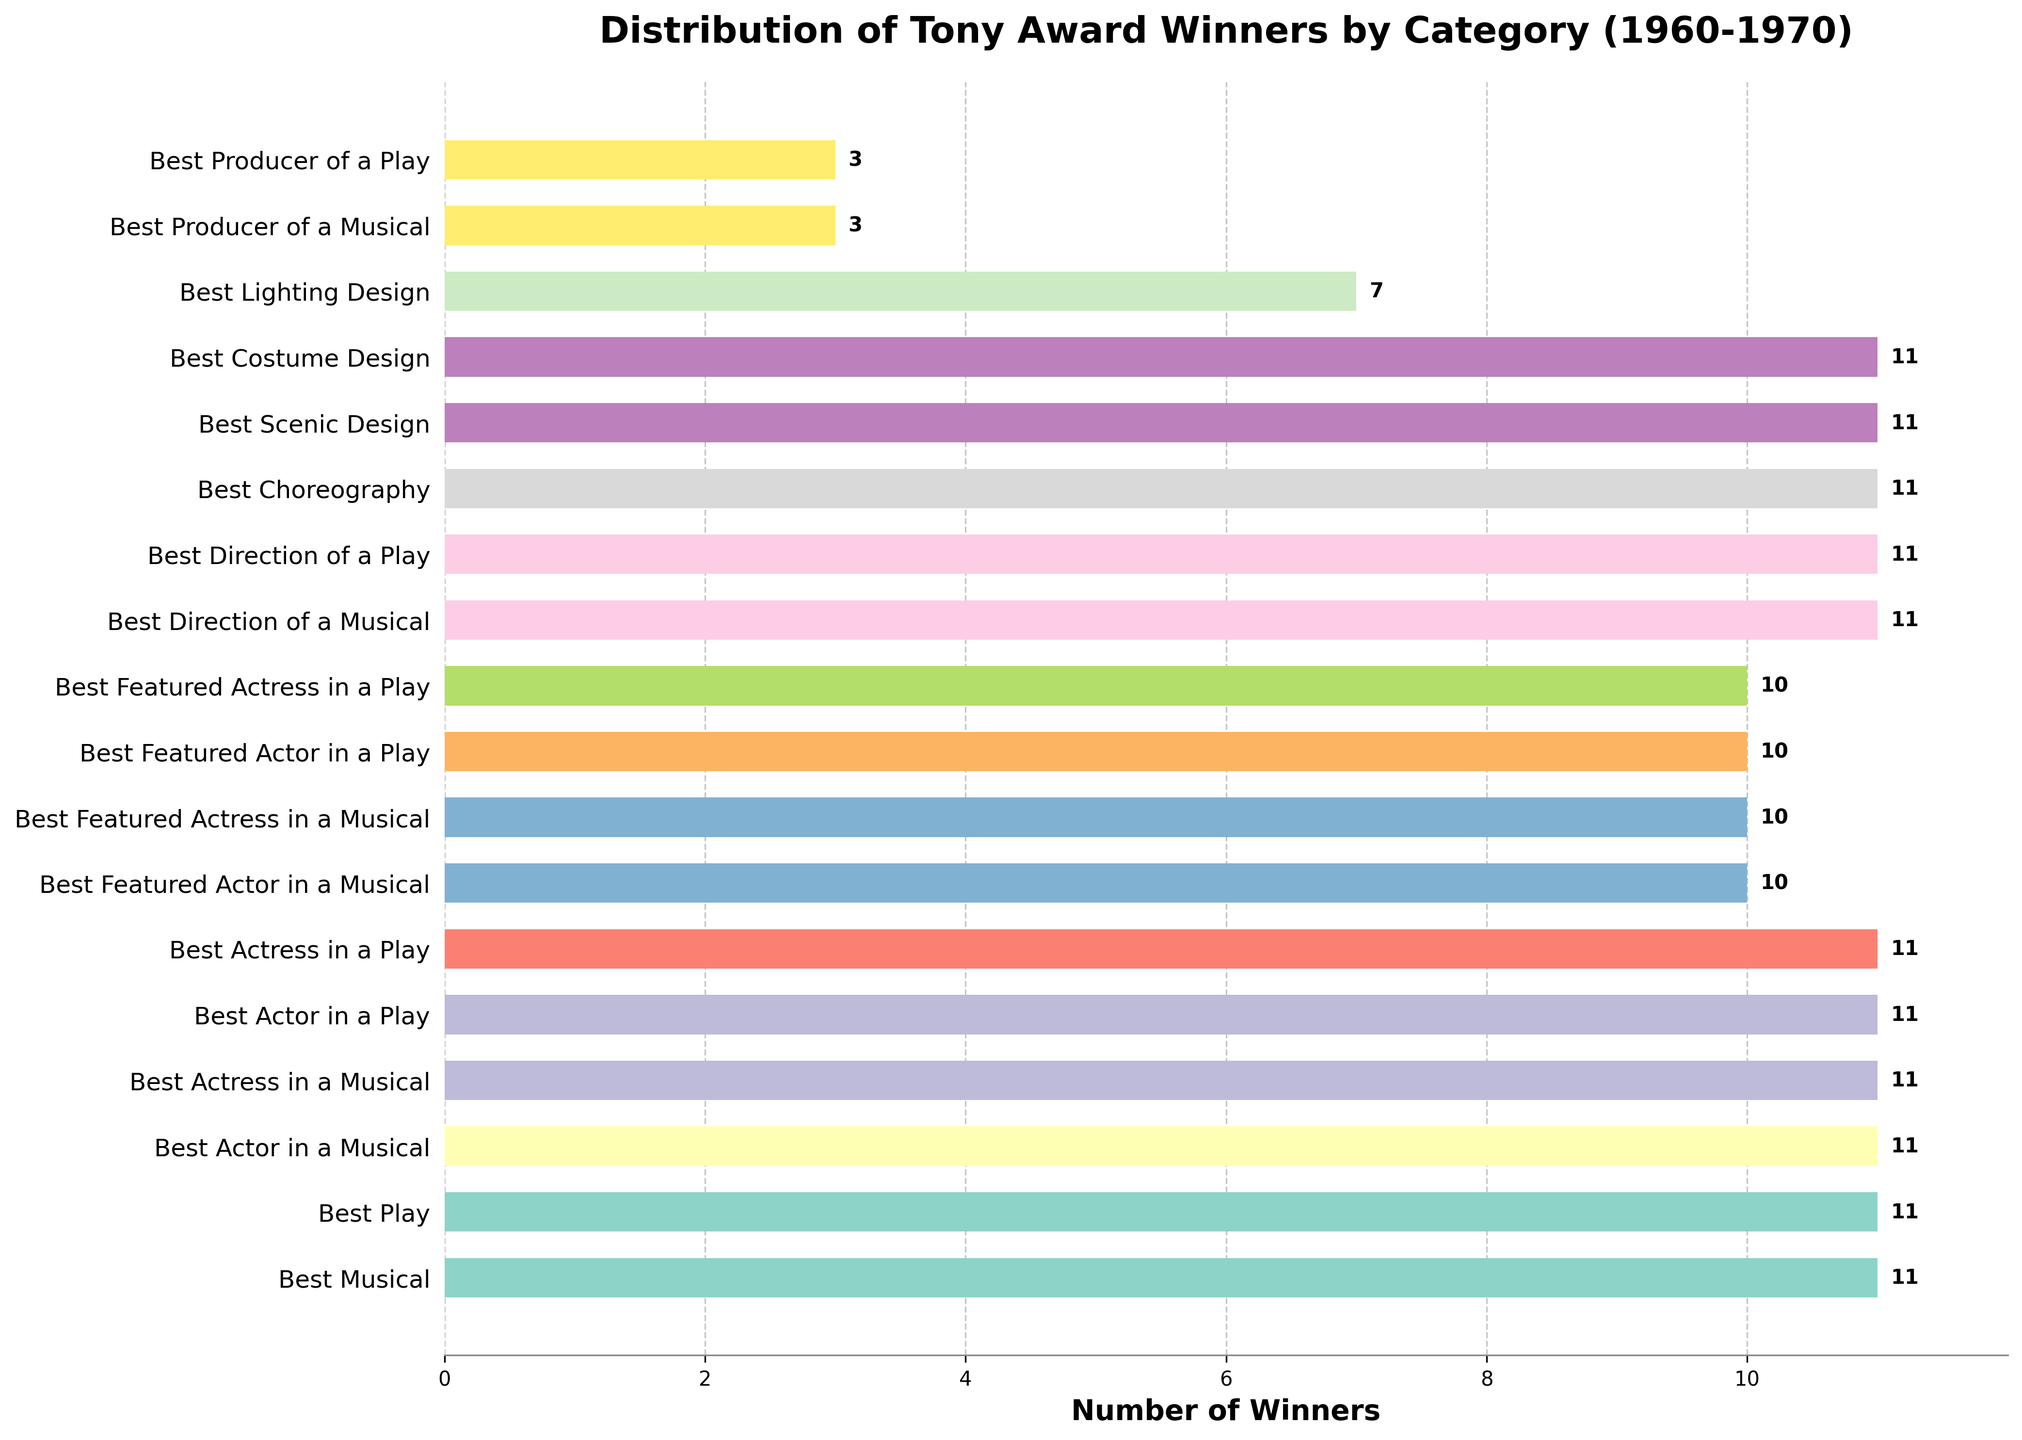What's the most awarded category? The most awarded categories are tied; many categories received 11 awards each. Visually, the bars for categories like Best Musical, Best Play, and others at the top have the same length.
Answer: Best Musical, Best Play, Best Actor in a Musical, Best Actress in a Musical, Best Actor in a Play, Best Actress in a Play, Best Direction of a Musical, Best Direction of a Play, Best Choreography, Best Scenic Design, Best Costume Design Which category received the least number of awards? By comparing the lengths of the bars, the shortest bars correspond to Best Producer of a Musical and Best Producer of a Play, both having notably fewer awards than other categories.
Answer: Best Producer of a Musical, Best Producer of a Play How many more awards did the category with the highest number receive compared to the one with the lowest? The highest number of awards any category received is 11, while the lowest is 3. The difference is calculated as 11 - 3.
Answer: 8 What's the total number of awards given in \*"Best Actor*" categories? Summing the awards for Best Actor in a Musical, Best Actress in a Musical, Best Actor in a Play, and Best Actress in a Play gives us: 11 + 11 + 11 + 11
Answer: 44 Do more communicative work categories (Best Direction of a Musical, Best Direction of a Play) receive more awards than technical categories (Best Scenic Design, Best Costume Design, Best Lighting Design)? Summing up the awards for communicative categories: Best Direction of a Musical (11) + Best Direction of a Play (11) = 22. Summing up for technical categories: Best Scenic Design (11) + Best Costume Design (11) + Best Lighting Design (7) = 29.
Answer: No Which category associated with a production role (excluding individual performance) has the fewest awards? Comparing the lengths of the bars, Best Producer of a Musical and Best Producer of a Play have the shortest bars among production roles.
Answer: Best Producer of a Musical and Best Producer of a Play How many different award categories were there between 1960 and 1970? Counting the number of bars in the chart gives us the total number of categories considered for the awards.
Answer: 18 